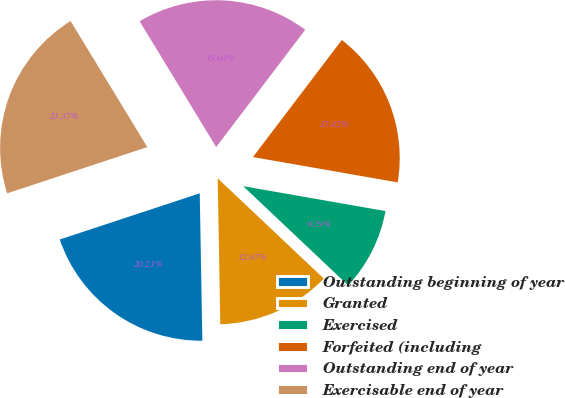Convert chart. <chart><loc_0><loc_0><loc_500><loc_500><pie_chart><fcel>Outstanding beginning of year<fcel>Granted<fcel>Exercised<fcel>Forfeited (including<fcel>Outstanding end of year<fcel>Exercisable end of year<nl><fcel>20.21%<fcel>12.67%<fcel>9.29%<fcel>17.42%<fcel>19.04%<fcel>21.37%<nl></chart> 